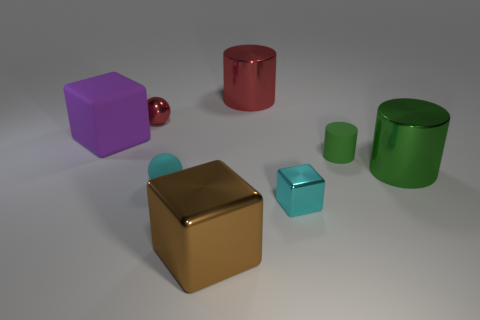How many metallic cylinders are the same size as the cyan shiny cube?
Offer a terse response. 0. The metallic cylinder that is the same color as the tiny metallic sphere is what size?
Ensure brevity in your answer.  Large. The shiny cylinder behind the sphere left of the cyan matte object is what color?
Provide a succinct answer. Red. Are there any tiny objects of the same color as the rubber cylinder?
Your response must be concise. No. The shiny cube that is the same size as the purple object is what color?
Ensure brevity in your answer.  Brown. Do the red object right of the big brown metallic object and the big green cylinder have the same material?
Offer a terse response. Yes. Are there any large red shiny things that are to the right of the red object that is right of the red object on the left side of the large red cylinder?
Your response must be concise. No. There is a red thing to the left of the tiny matte sphere; does it have the same shape as the big brown thing?
Your answer should be very brief. No. There is a red shiny object that is behind the tiny ball behind the purple cube; what is its shape?
Keep it short and to the point. Cylinder. How big is the green thing that is to the left of the large shiny cylinder that is in front of the red object that is to the right of the tiny red ball?
Give a very brief answer. Small. 